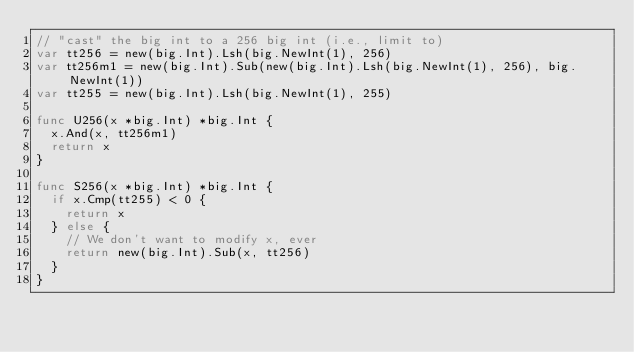<code> <loc_0><loc_0><loc_500><loc_500><_Go_>// "cast" the big int to a 256 big int (i.e., limit to)
var tt256 = new(big.Int).Lsh(big.NewInt(1), 256)
var tt256m1 = new(big.Int).Sub(new(big.Int).Lsh(big.NewInt(1), 256), big.NewInt(1))
var tt255 = new(big.Int).Lsh(big.NewInt(1), 255)

func U256(x *big.Int) *big.Int {
	x.And(x, tt256m1)
	return x
}

func S256(x *big.Int) *big.Int {
	if x.Cmp(tt255) < 0 {
		return x
	} else {
		// We don't want to modify x, ever
		return new(big.Int).Sub(x, tt256)
	}
}
</code> 